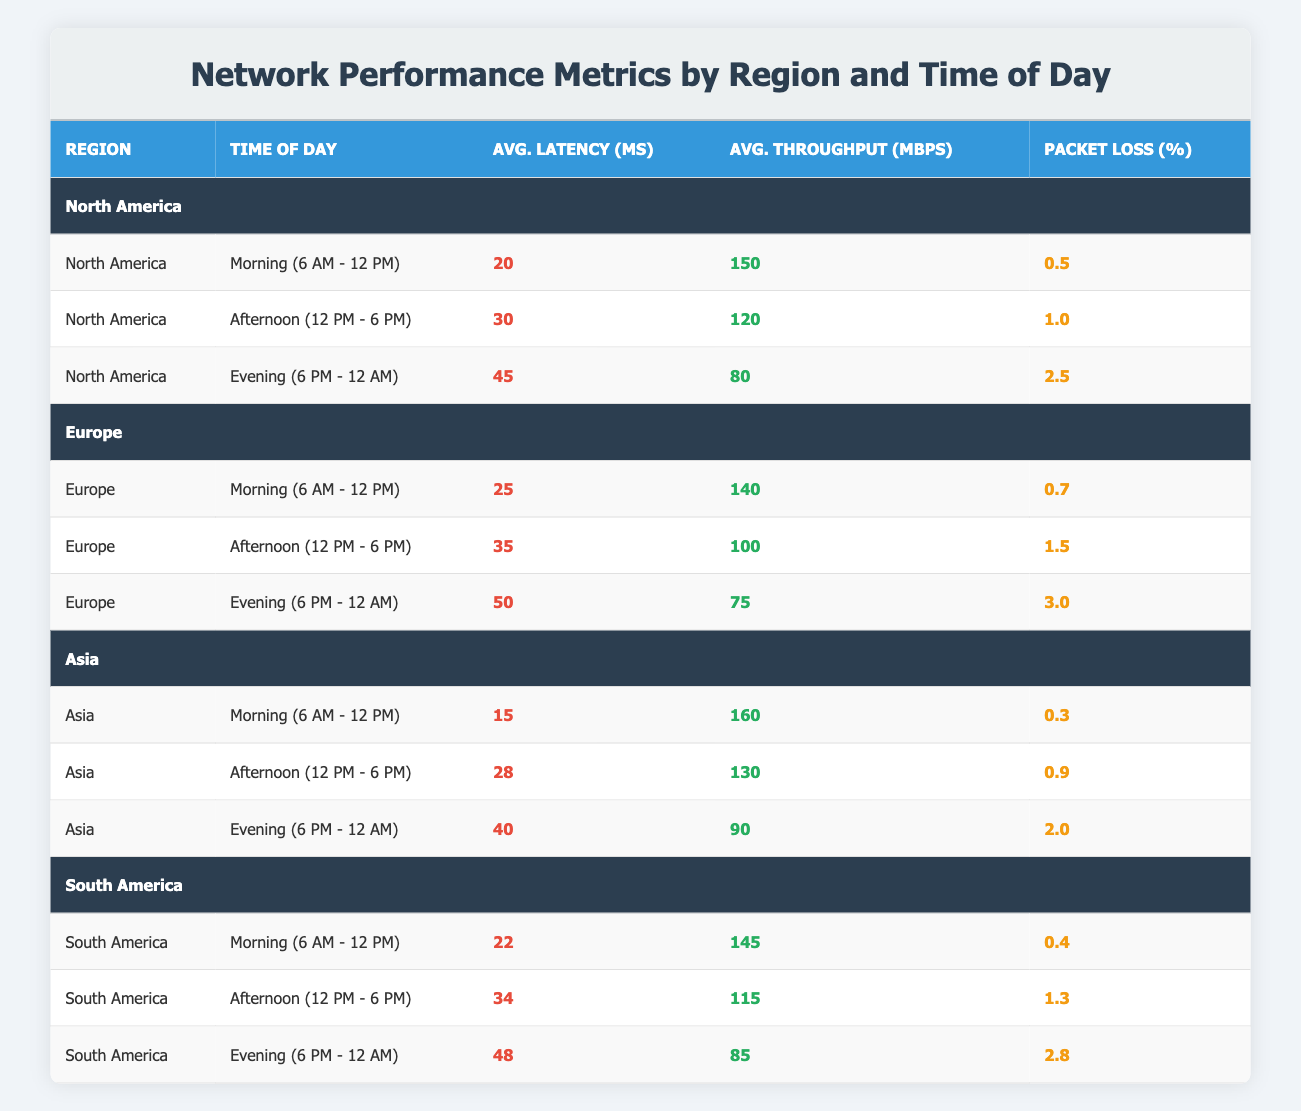What is the average latency in Asia during the morning? The average latency during the morning in Asia is provided directly in the table as 15 milliseconds.
Answer: 15 ms What is the packet loss percentage for North America in the evening? Packet loss for North America in the evening is listed in the table as 2.5%.
Answer: 2.5% Which region has the highest average throughput during the afternoon? By examining the afternoon average throughputs listed, North America has the highest value at 120 Mbps, compared to Europe at 100 Mbps and Asia at 130 Mbps.
Answer: Asia Is the average latency higher in the evening than in the afternoon for Europe? The average latency in the evening for Europe is 50 ms, while in the afternoon it is 35 ms. Therefore, 50 ms > 35 ms, confirming that the latency is indeed higher in the evening.
Answer: Yes What is the total average throughput across all regions during the morning? The average throughputs during the morning are: North America (150), Europe (140), Asia (160), and South America (145). Summing these gives: 150 + 140 + 160 + 145 = 595 Mbps. Therefore, the total average throughput is 595 Mbps.
Answer: 595 Mbps How does the packet loss percentage in South America during the evening compare to Asia during the same time? South America has a packet loss of 2.8% in the evening, while Asia has a packet loss of 2.0%. Thus, 2.8% > 2.0%, indicating South America has a higher packet loss percentage.
Answer: South America has higher packet loss What is the difference in average latency between North America and Asia during the evening? The average latency for North America in the evening is 45 ms, while for Asia, it is 40 ms. The difference is calculated as 45 ms - 40 ms = 5 ms.
Answer: 5 ms Which time of day has the lowest average latency across all regions? By reviewing the morning times: North America (20), Europe (25), Asia (15), and South America (22), Asia has the lowest with 15 ms during the morning.
Answer: Morning (Asia, 15 ms) What is the average packet loss percentage for North America? The packet losses in North America during morning, afternoon, and evening are 0.5%, 1.0%, and 2.5%. The average is calculated as (0.5 + 1.0 + 2.5) / 3 = 1.0%.
Answer: 1.0% 